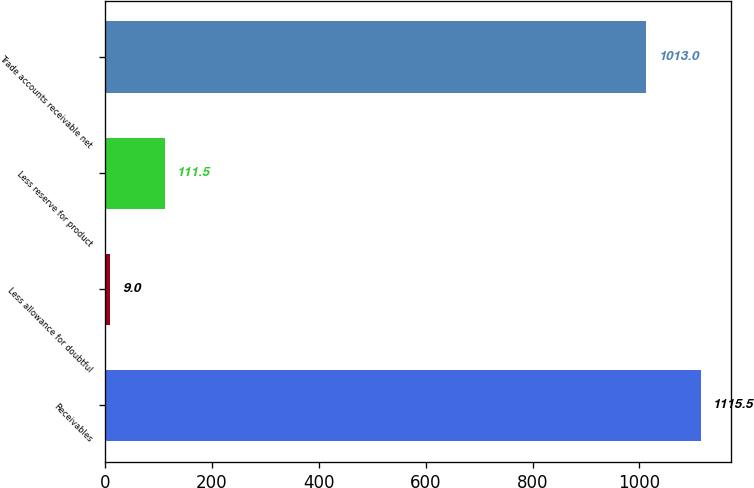Convert chart to OTSL. <chart><loc_0><loc_0><loc_500><loc_500><bar_chart><fcel>Receivables<fcel>Less allowance for doubtful<fcel>Less reserve for product<fcel>Trade accounts receivable net<nl><fcel>1115.5<fcel>9<fcel>111.5<fcel>1013<nl></chart> 